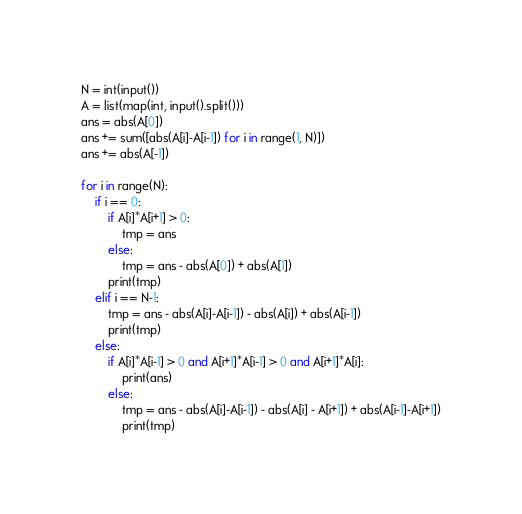Convert code to text. <code><loc_0><loc_0><loc_500><loc_500><_Python_>N = int(input())
A = list(map(int, input().split()))
ans = abs(A[0])
ans += sum([abs(A[i]-A[i-1]) for i in range(1, N)])
ans += abs(A[-1])

for i in range(N):
    if i == 0:
        if A[i]*A[i+1] > 0:
            tmp = ans 
        else:
            tmp = ans - abs(A[0]) + abs(A[1])
        print(tmp)
    elif i == N-1:
        tmp = ans - abs(A[i]-A[i-1]) - abs(A[i]) + abs(A[i-1])
        print(tmp)
    else:
        if A[i]*A[i-1] > 0 and A[i+1]*A[i-1] > 0 and A[i+1]*A[i]:
            print(ans)
        else:
            tmp = ans - abs(A[i]-A[i-1]) - abs(A[i] - A[i+1]) + abs(A[i-1]-A[i+1])
            print(tmp)</code> 